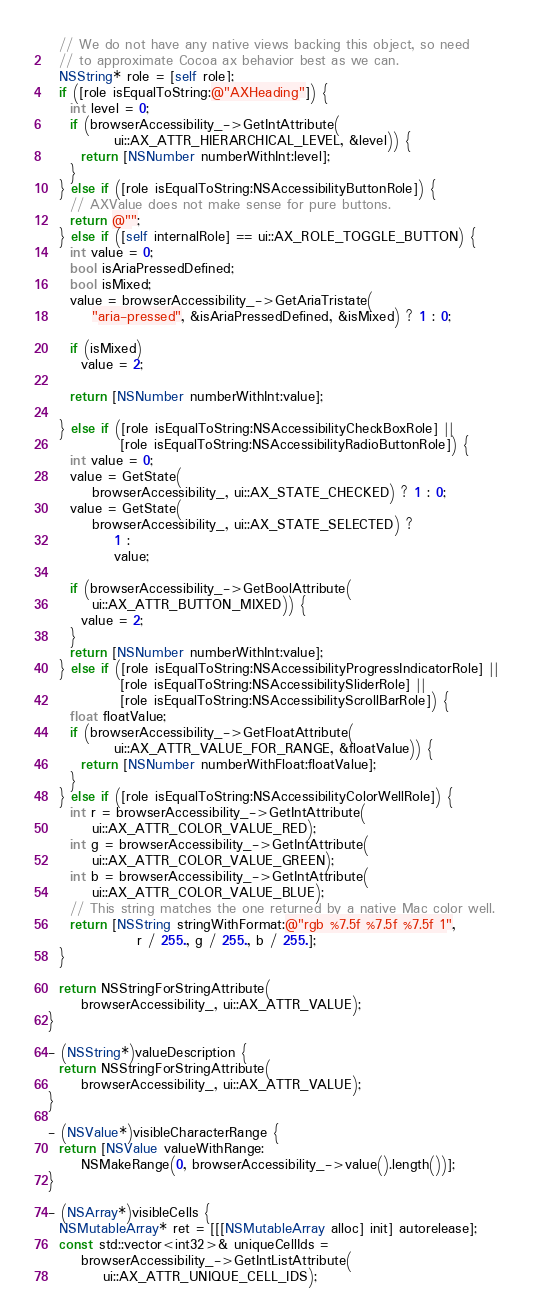<code> <loc_0><loc_0><loc_500><loc_500><_ObjectiveC_>  // We do not have any native views backing this object, so need
  // to approximate Cocoa ax behavior best as we can.
  NSString* role = [self role];
  if ([role isEqualToString:@"AXHeading"]) {
    int level = 0;
    if (browserAccessibility_->GetIntAttribute(
            ui::AX_ATTR_HIERARCHICAL_LEVEL, &level)) {
      return [NSNumber numberWithInt:level];
    }
  } else if ([role isEqualToString:NSAccessibilityButtonRole]) {
    // AXValue does not make sense for pure buttons.
    return @"";
  } else if ([self internalRole] == ui::AX_ROLE_TOGGLE_BUTTON) {
    int value = 0;
    bool isAriaPressedDefined;
    bool isMixed;
    value = browserAccessibility_->GetAriaTristate(
        "aria-pressed", &isAriaPressedDefined, &isMixed) ? 1 : 0;

    if (isMixed)
      value = 2;

    return [NSNumber numberWithInt:value];

  } else if ([role isEqualToString:NSAccessibilityCheckBoxRole] ||
             [role isEqualToString:NSAccessibilityRadioButtonRole]) {
    int value = 0;
    value = GetState(
        browserAccessibility_, ui::AX_STATE_CHECKED) ? 1 : 0;
    value = GetState(
        browserAccessibility_, ui::AX_STATE_SELECTED) ?
            1 :
            value;

    if (browserAccessibility_->GetBoolAttribute(
        ui::AX_ATTR_BUTTON_MIXED)) {
      value = 2;
    }
    return [NSNumber numberWithInt:value];
  } else if ([role isEqualToString:NSAccessibilityProgressIndicatorRole] ||
             [role isEqualToString:NSAccessibilitySliderRole] ||
             [role isEqualToString:NSAccessibilityScrollBarRole]) {
    float floatValue;
    if (browserAccessibility_->GetFloatAttribute(
            ui::AX_ATTR_VALUE_FOR_RANGE, &floatValue)) {
      return [NSNumber numberWithFloat:floatValue];
    }
  } else if ([role isEqualToString:NSAccessibilityColorWellRole]) {
    int r = browserAccessibility_->GetIntAttribute(
        ui::AX_ATTR_COLOR_VALUE_RED);
    int g = browserAccessibility_->GetIntAttribute(
        ui::AX_ATTR_COLOR_VALUE_GREEN);
    int b = browserAccessibility_->GetIntAttribute(
        ui::AX_ATTR_COLOR_VALUE_BLUE);
    // This string matches the one returned by a native Mac color well.
    return [NSString stringWithFormat:@"rgb %7.5f %7.5f %7.5f 1",
                r / 255., g / 255., b / 255.];
  }

  return NSStringForStringAttribute(
      browserAccessibility_, ui::AX_ATTR_VALUE);
}

- (NSString*)valueDescription {
  return NSStringForStringAttribute(
      browserAccessibility_, ui::AX_ATTR_VALUE);
}

- (NSValue*)visibleCharacterRange {
  return [NSValue valueWithRange:
      NSMakeRange(0, browserAccessibility_->value().length())];
}

- (NSArray*)visibleCells {
  NSMutableArray* ret = [[[NSMutableArray alloc] init] autorelease];
  const std::vector<int32>& uniqueCellIds =
      browserAccessibility_->GetIntListAttribute(
          ui::AX_ATTR_UNIQUE_CELL_IDS);</code> 